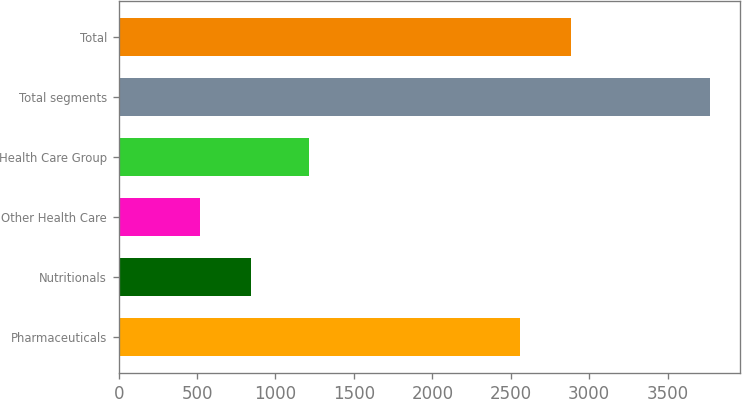<chart> <loc_0><loc_0><loc_500><loc_500><bar_chart><fcel>Pharmaceuticals<fcel>Nutritionals<fcel>Other Health Care<fcel>Health Care Group<fcel>Total segments<fcel>Total<nl><fcel>2559<fcel>842.5<fcel>517<fcel>1213<fcel>3772<fcel>2884.5<nl></chart> 